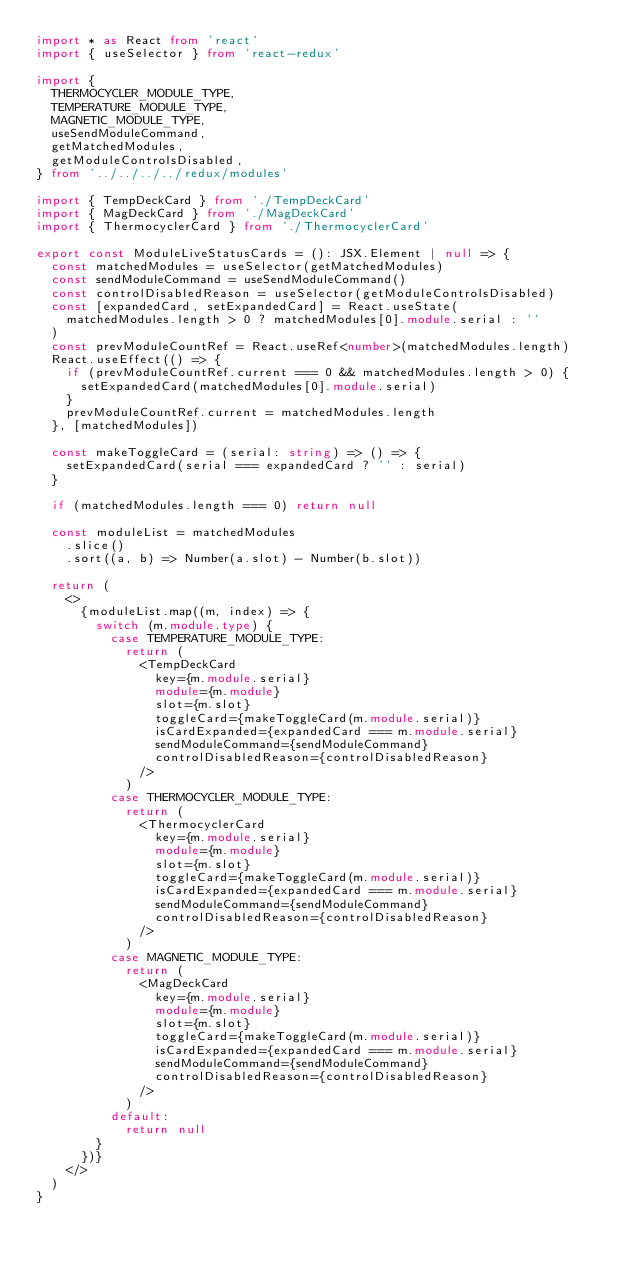Convert code to text. <code><loc_0><loc_0><loc_500><loc_500><_TypeScript_>import * as React from 'react'
import { useSelector } from 'react-redux'

import {
  THERMOCYCLER_MODULE_TYPE,
  TEMPERATURE_MODULE_TYPE,
  MAGNETIC_MODULE_TYPE,
  useSendModuleCommand,
  getMatchedModules,
  getModuleControlsDisabled,
} from '../../../../redux/modules'

import { TempDeckCard } from './TempDeckCard'
import { MagDeckCard } from './MagDeckCard'
import { ThermocyclerCard } from './ThermocyclerCard'

export const ModuleLiveStatusCards = (): JSX.Element | null => {
  const matchedModules = useSelector(getMatchedModules)
  const sendModuleCommand = useSendModuleCommand()
  const controlDisabledReason = useSelector(getModuleControlsDisabled)
  const [expandedCard, setExpandedCard] = React.useState(
    matchedModules.length > 0 ? matchedModules[0].module.serial : ''
  )
  const prevModuleCountRef = React.useRef<number>(matchedModules.length)
  React.useEffect(() => {
    if (prevModuleCountRef.current === 0 && matchedModules.length > 0) {
      setExpandedCard(matchedModules[0].module.serial)
    }
    prevModuleCountRef.current = matchedModules.length
  }, [matchedModules])

  const makeToggleCard = (serial: string) => () => {
    setExpandedCard(serial === expandedCard ? '' : serial)
  }

  if (matchedModules.length === 0) return null

  const moduleList = matchedModules
    .slice()
    .sort((a, b) => Number(a.slot) - Number(b.slot))

  return (
    <>
      {moduleList.map((m, index) => {
        switch (m.module.type) {
          case TEMPERATURE_MODULE_TYPE:
            return (
              <TempDeckCard
                key={m.module.serial}
                module={m.module}
                slot={m.slot}
                toggleCard={makeToggleCard(m.module.serial)}
                isCardExpanded={expandedCard === m.module.serial}
                sendModuleCommand={sendModuleCommand}
                controlDisabledReason={controlDisabledReason}
              />
            )
          case THERMOCYCLER_MODULE_TYPE:
            return (
              <ThermocyclerCard
                key={m.module.serial}
                module={m.module}
                slot={m.slot}
                toggleCard={makeToggleCard(m.module.serial)}
                isCardExpanded={expandedCard === m.module.serial}
                sendModuleCommand={sendModuleCommand}
                controlDisabledReason={controlDisabledReason}
              />
            )
          case MAGNETIC_MODULE_TYPE:
            return (
              <MagDeckCard
                key={m.module.serial}
                module={m.module}
                slot={m.slot}
                toggleCard={makeToggleCard(m.module.serial)}
                isCardExpanded={expandedCard === m.module.serial}
                sendModuleCommand={sendModuleCommand}
                controlDisabledReason={controlDisabledReason}
              />
            )
          default:
            return null
        }
      })}
    </>
  )
}
</code> 